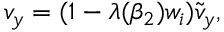Convert formula to latex. <formula><loc_0><loc_0><loc_500><loc_500>v _ { y } = ( 1 - \lambda ( \beta _ { 2 } ) w _ { i } ) \tilde { v } _ { y } ,</formula> 